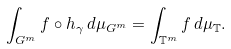Convert formula to latex. <formula><loc_0><loc_0><loc_500><loc_500>\int _ { G ^ { m } } f \circ h _ { \gamma } \, d \mu _ { G ^ { m } } = \int _ { { \mathbb { T } } ^ { m } } f \, d \mu _ { \mathbb { T } } .</formula> 